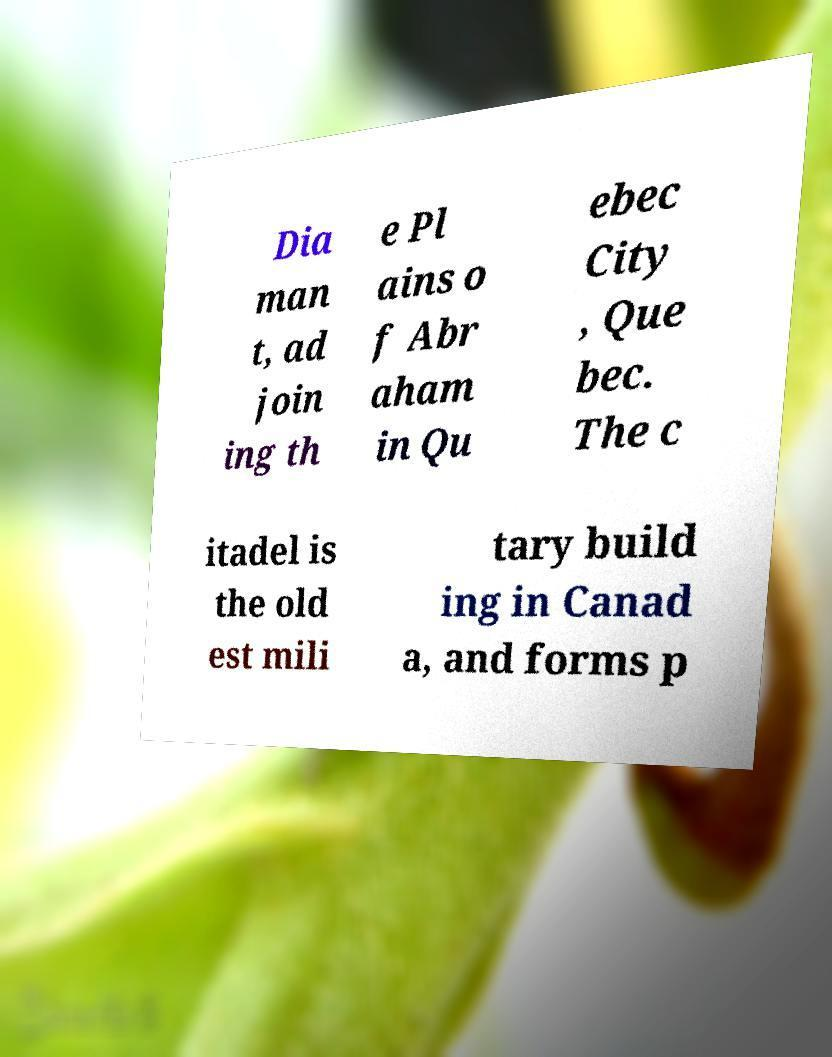Please read and relay the text visible in this image. What does it say? Dia man t, ad join ing th e Pl ains o f Abr aham in Qu ebec City , Que bec. The c itadel is the old est mili tary build ing in Canad a, and forms p 